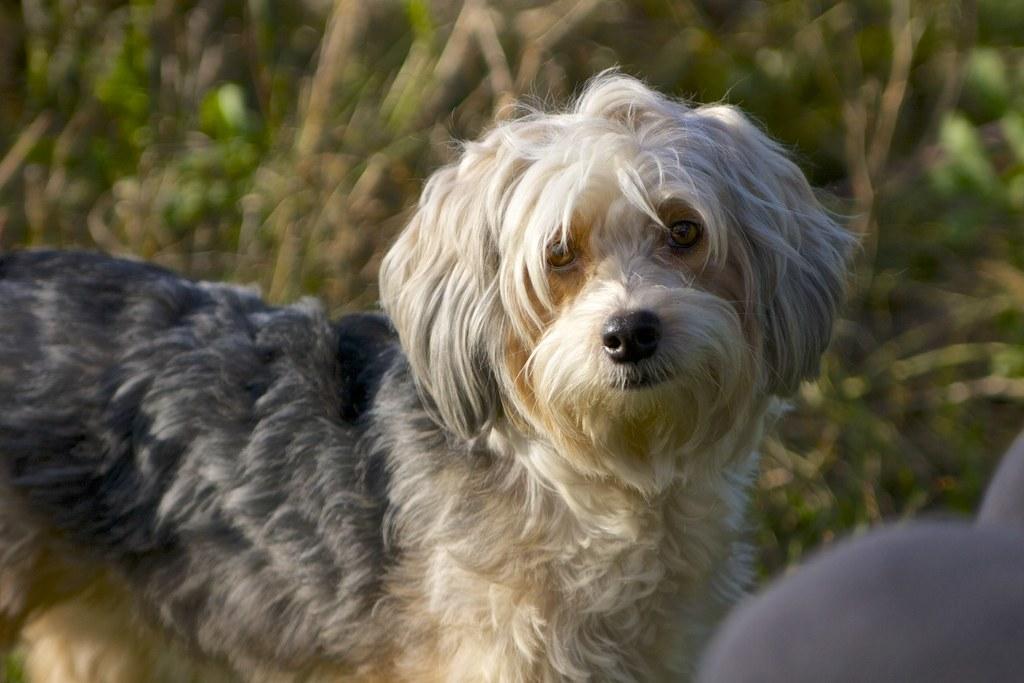In one or two sentences, can you explain what this image depicts? In the center of the image, we can see a dog and the background is blurry. 